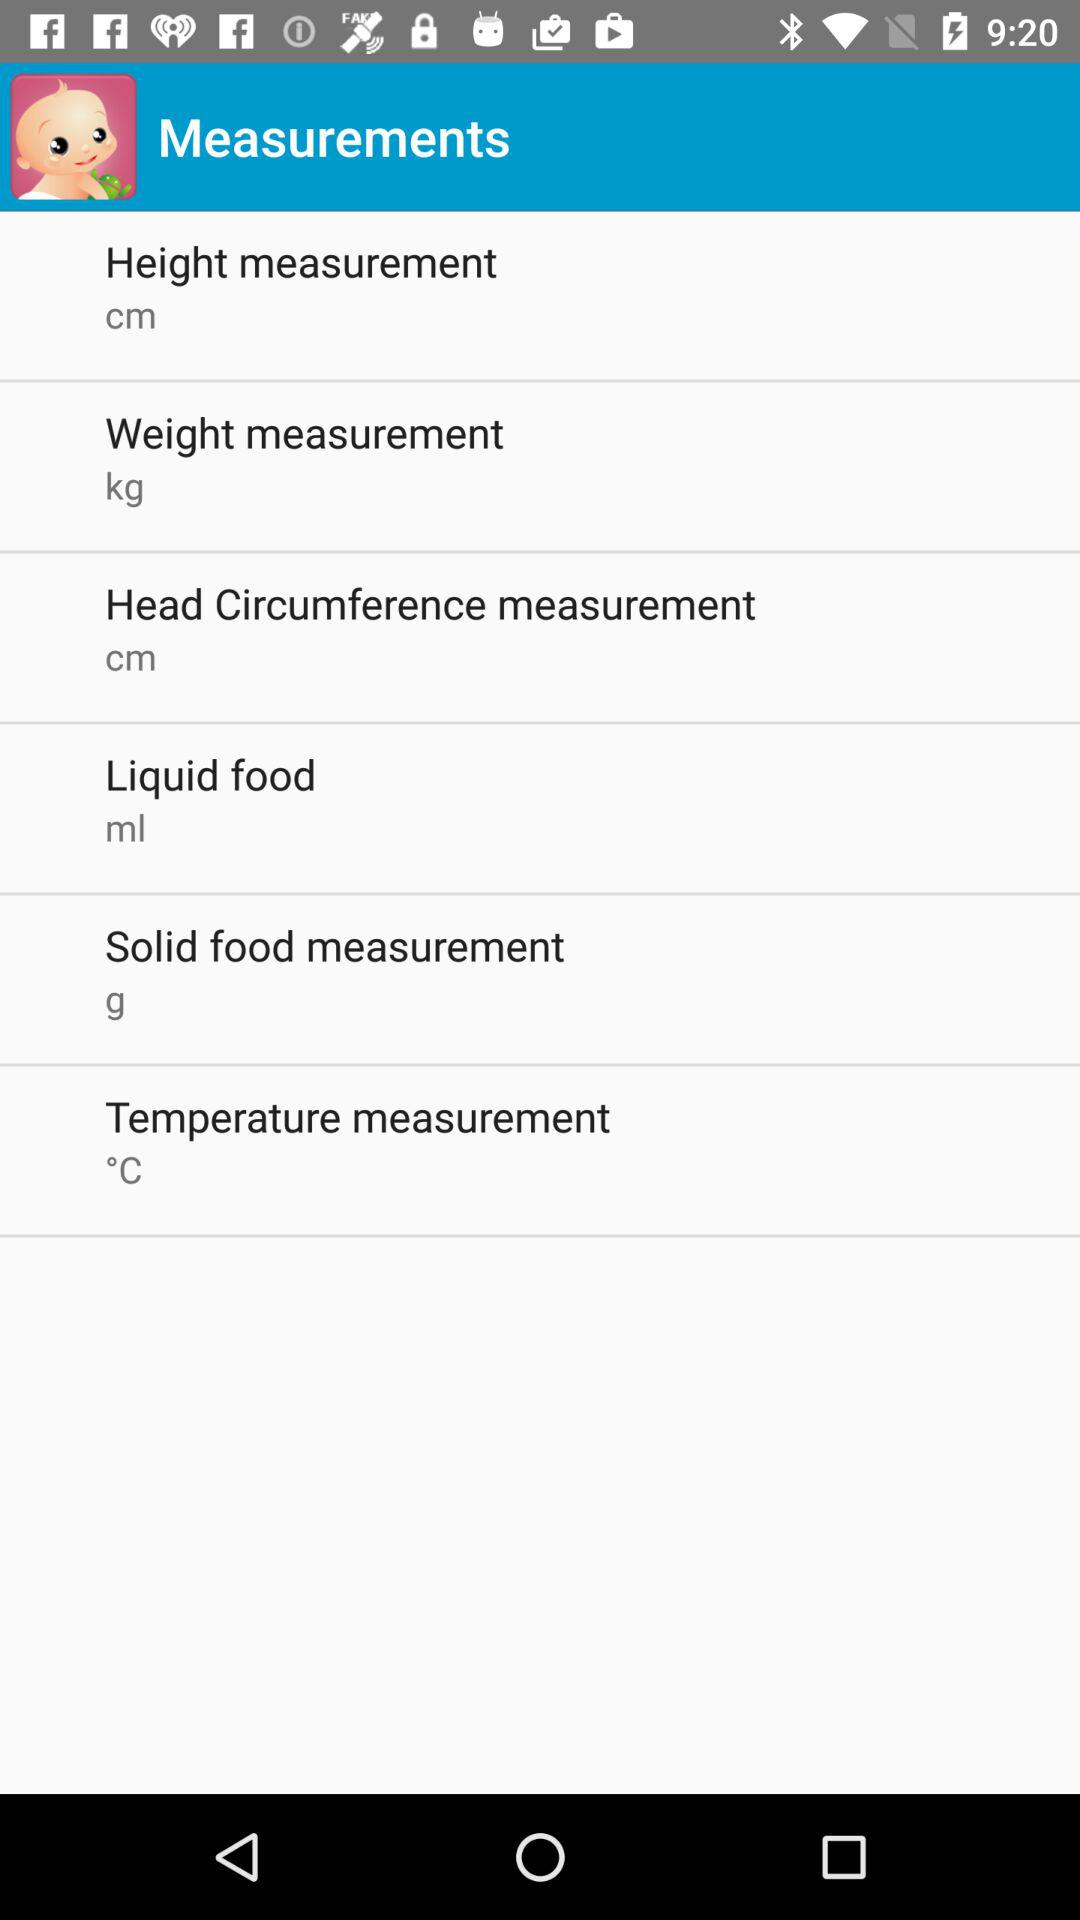What is the unit of temperature? The unit of temperature is °C. 